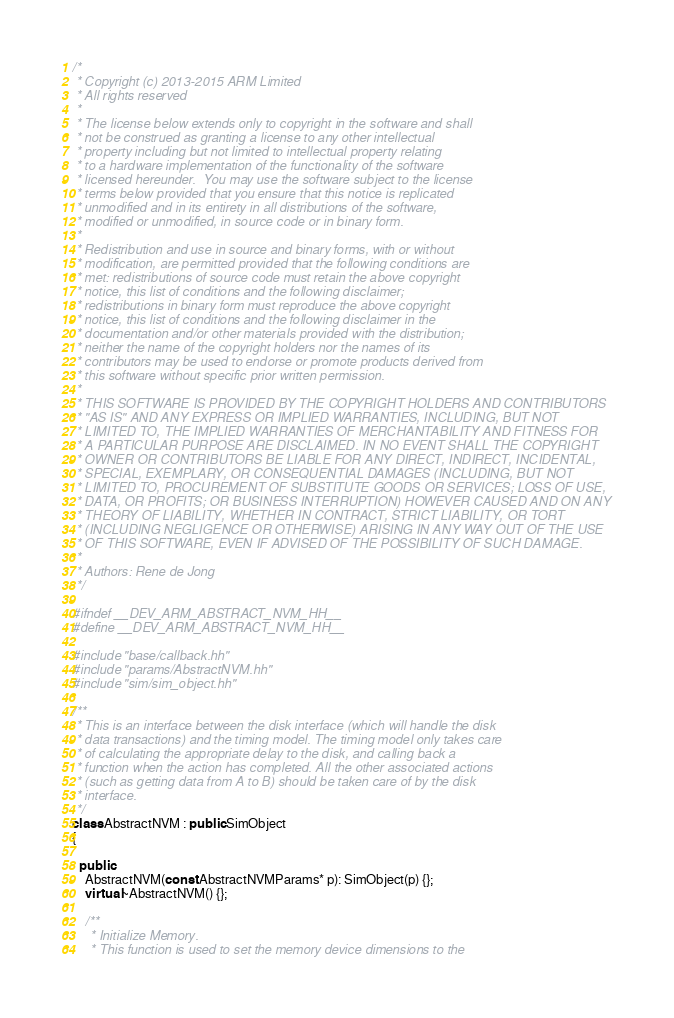<code> <loc_0><loc_0><loc_500><loc_500><_C++_>/*
 * Copyright (c) 2013-2015 ARM Limited
 * All rights reserved
 *
 * The license below extends only to copyright in the software and shall
 * not be construed as granting a license to any other intellectual
 * property including but not limited to intellectual property relating
 * to a hardware implementation of the functionality of the software
 * licensed hereunder.  You may use the software subject to the license
 * terms below provided that you ensure that this notice is replicated
 * unmodified and in its entirety in all distributions of the software,
 * modified or unmodified, in source code or in binary form.
 *
 * Redistribution and use in source and binary forms, with or without
 * modification, are permitted provided that the following conditions are
 * met: redistributions of source code must retain the above copyright
 * notice, this list of conditions and the following disclaimer;
 * redistributions in binary form must reproduce the above copyright
 * notice, this list of conditions and the following disclaimer in the
 * documentation and/or other materials provided with the distribution;
 * neither the name of the copyright holders nor the names of its
 * contributors may be used to endorse or promote products derived from
 * this software without specific prior written permission.
 *
 * THIS SOFTWARE IS PROVIDED BY THE COPYRIGHT HOLDERS AND CONTRIBUTORS
 * "AS IS" AND ANY EXPRESS OR IMPLIED WARRANTIES, INCLUDING, BUT NOT
 * LIMITED TO, THE IMPLIED WARRANTIES OF MERCHANTABILITY AND FITNESS FOR
 * A PARTICULAR PURPOSE ARE DISCLAIMED. IN NO EVENT SHALL THE COPYRIGHT
 * OWNER OR CONTRIBUTORS BE LIABLE FOR ANY DIRECT, INDIRECT, INCIDENTAL,
 * SPECIAL, EXEMPLARY, OR CONSEQUENTIAL DAMAGES (INCLUDING, BUT NOT
 * LIMITED TO, PROCUREMENT OF SUBSTITUTE GOODS OR SERVICES; LOSS OF USE,
 * DATA, OR PROFITS; OR BUSINESS INTERRUPTION) HOWEVER CAUSED AND ON ANY
 * THEORY OF LIABILITY, WHETHER IN CONTRACT, STRICT LIABILITY, OR TORT
 * (INCLUDING NEGLIGENCE OR OTHERWISE) ARISING IN ANY WAY OUT OF THE USE
 * OF THIS SOFTWARE, EVEN IF ADVISED OF THE POSSIBILITY OF SUCH DAMAGE.
 *
 * Authors: Rene de Jong
 */

#ifndef __DEV_ARM_ABSTRACT_NVM_HH__
#define __DEV_ARM_ABSTRACT_NVM_HH__

#include "base/callback.hh"
#include "params/AbstractNVM.hh"
#include "sim/sim_object.hh"

/**
 * This is an interface between the disk interface (which will handle the disk
 * data transactions) and the timing model. The timing model only takes care
 * of calculating the appropriate delay to the disk, and calling back a
 * function when the action has completed. All the other associated actions
 * (such as getting data from A to B) should be taken care of by the disk
 * interface.
 */
class AbstractNVM : public SimObject
{

  public:
    AbstractNVM(const AbstractNVMParams* p): SimObject(p) {};
    virtual ~AbstractNVM() {};

    /**
     * Initialize Memory.
     * This function is used to set the memory device dimensions to the</code> 